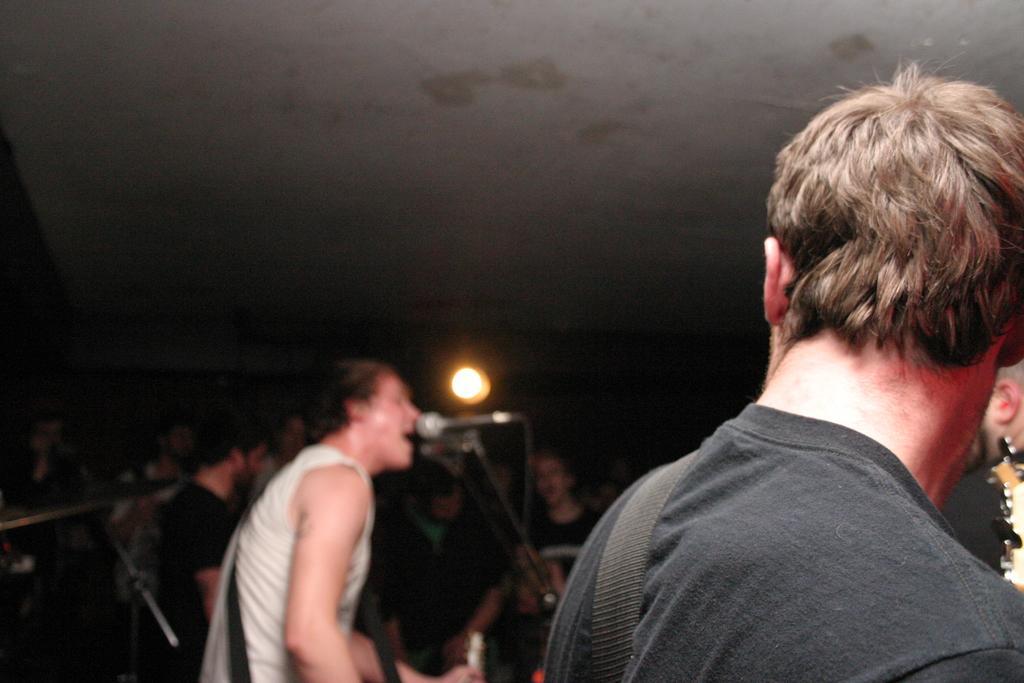Could you give a brief overview of what you see in this image? In this image in the front there are persons performing and there are musical instruments and there is a light. 